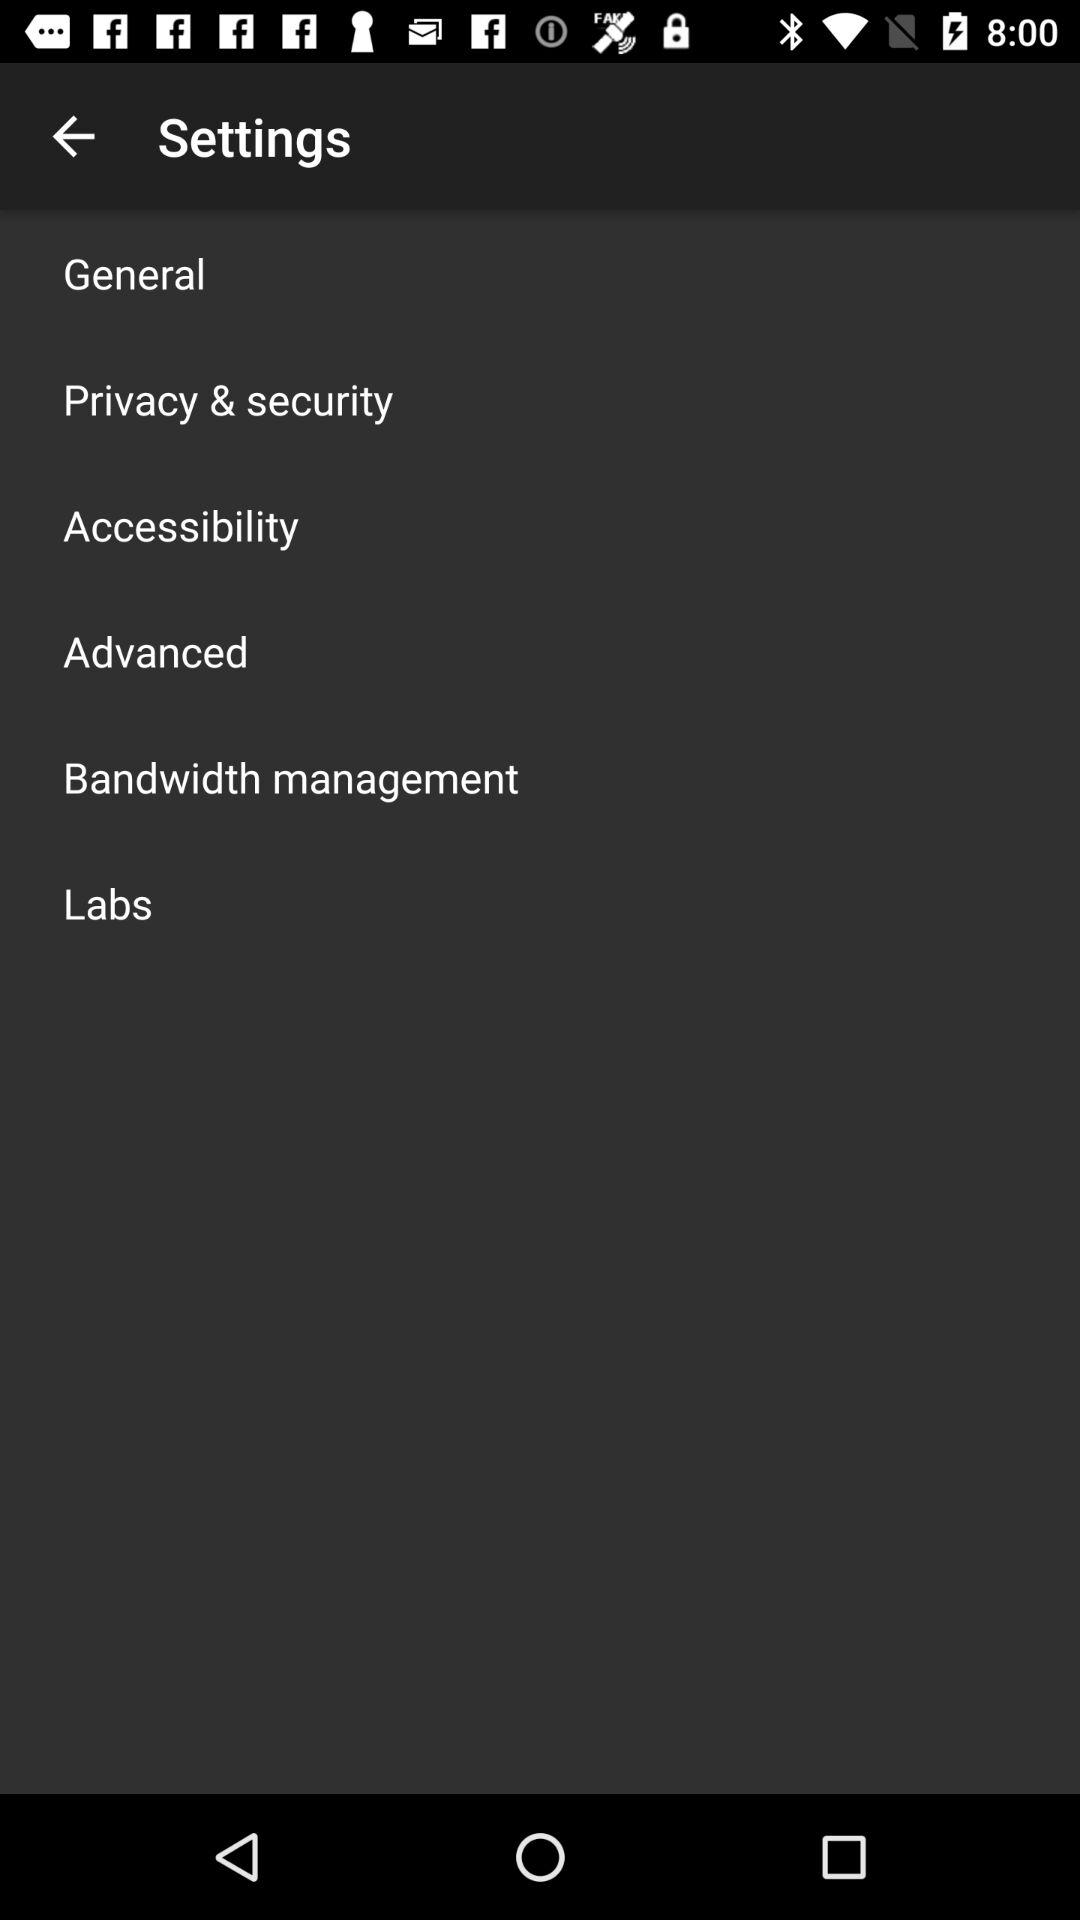How many settings are there in the settings menu?
Answer the question using a single word or phrase. 6 